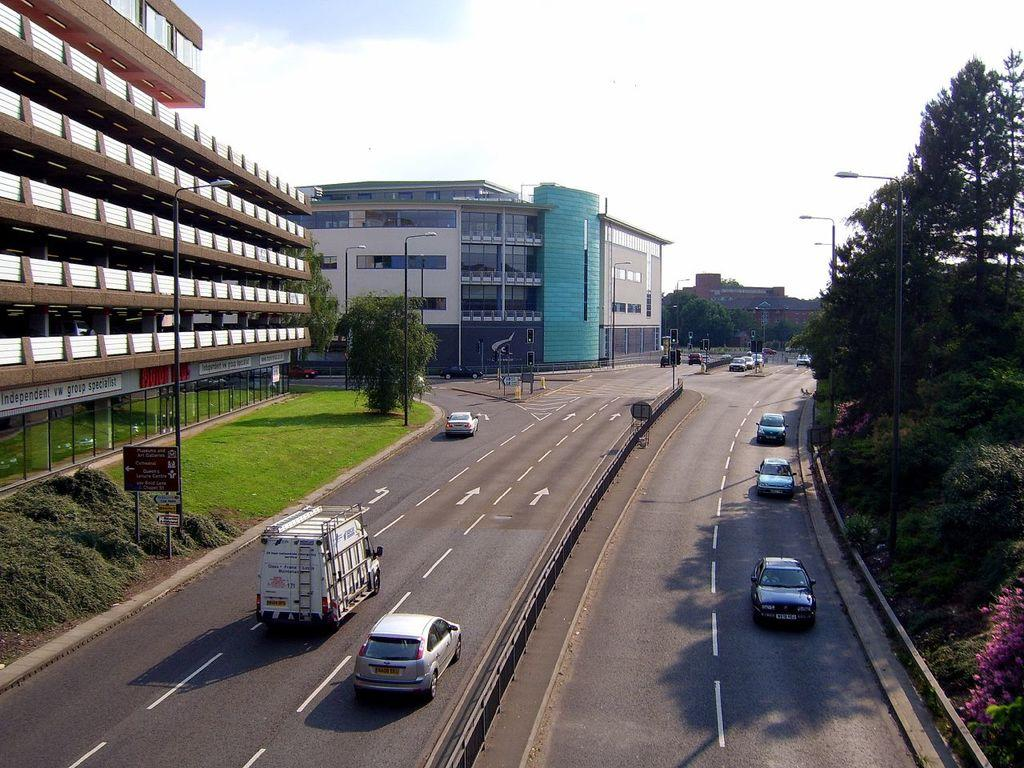What can be seen on the road in the image? There are vehicles on the road in the image. What type of vegetation is on the right side of the image? There are trees on the right side of the image. What type of structures are on the left side of the image? There are buildings on the left side of the image. What is visible above the scene in the image? The sky is visible above the scene in the image. Where is the sea visible in the image? There is no sea present in the image. What type of cracker is being used to build the buildings in the image? There are no crackers present in the image; the buildings are made of solid materials. 